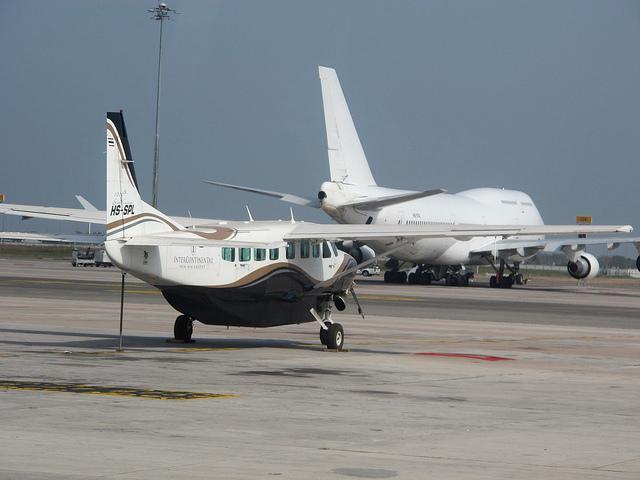How many planes are in the picture?
Give a very brief answer. 2. How many airplanes are there?
Give a very brief answer. 2. How many people are climbing the stairs?
Give a very brief answer. 0. 